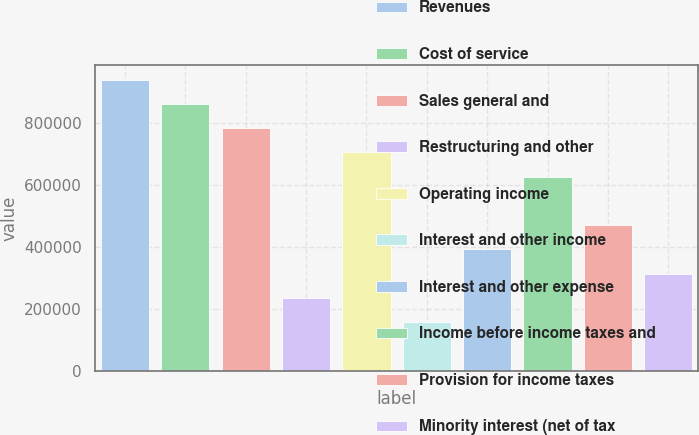Convert chart to OTSL. <chart><loc_0><loc_0><loc_500><loc_500><bar_chart><fcel>Revenues<fcel>Cost of service<fcel>Sales general and<fcel>Restructuring and other<fcel>Operating income<fcel>Interest and other income<fcel>Interest and other expense<fcel>Income before income taxes and<fcel>Provision for income taxes<fcel>Minority interest (net of tax<nl><fcel>941197<fcel>862764<fcel>784331<fcel>235301<fcel>705898<fcel>156868<fcel>392167<fcel>627465<fcel>470600<fcel>313734<nl></chart> 